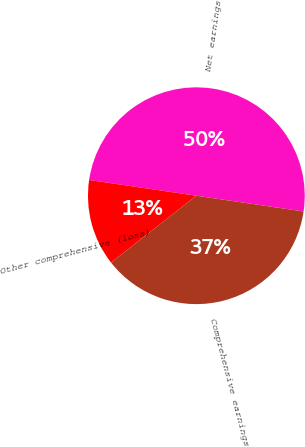<chart> <loc_0><loc_0><loc_500><loc_500><pie_chart><fcel>Net earnings<fcel>Other comprehensive (loss)<fcel>Comprehensive earnings<nl><fcel>50.0%<fcel>12.9%<fcel>37.1%<nl></chart> 